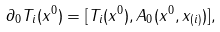Convert formula to latex. <formula><loc_0><loc_0><loc_500><loc_500>& \partial _ { 0 } T _ { i } ( x ^ { 0 } ) = [ T _ { i } ( x ^ { 0 } ) , A _ { 0 } ( x ^ { 0 } , x _ { ( i ) } ) ] ,</formula> 